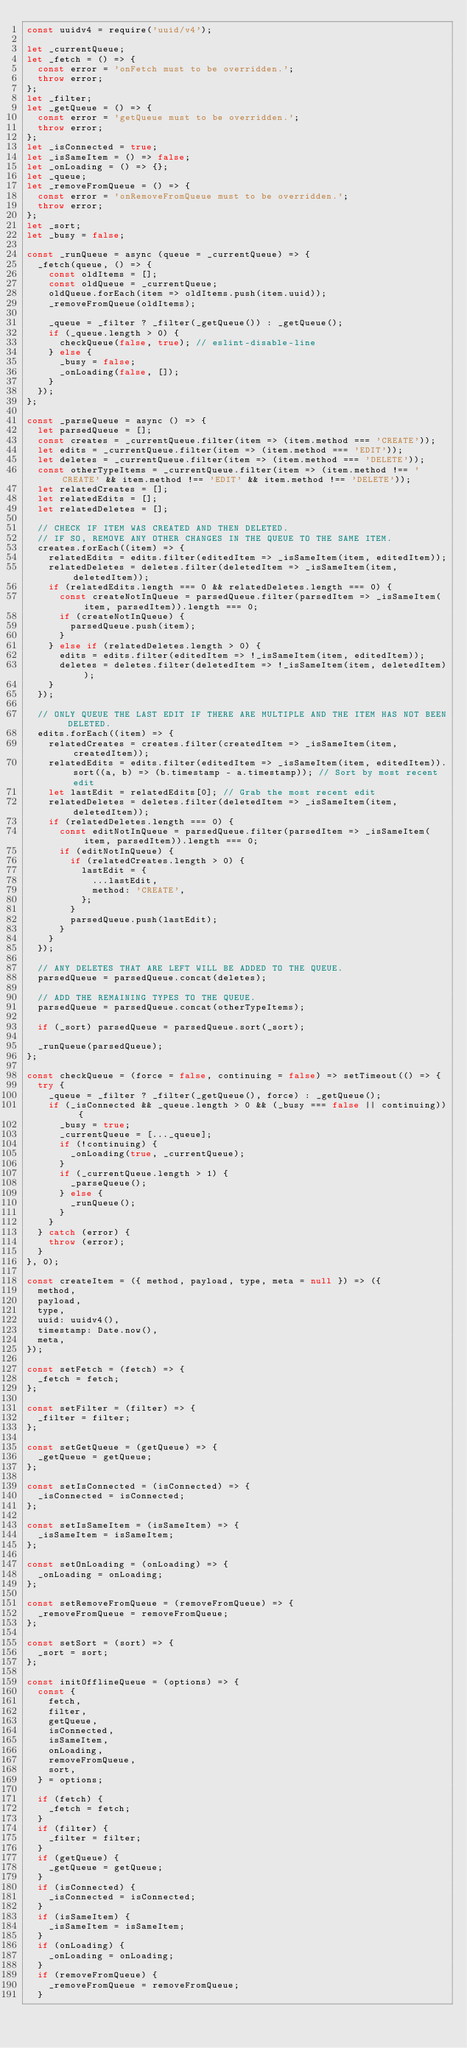Convert code to text. <code><loc_0><loc_0><loc_500><loc_500><_JavaScript_>const uuidv4 = require('uuid/v4');

let _currentQueue;
let _fetch = () => {
  const error = 'onFetch must to be overridden.';
  throw error;
};
let _filter;
let _getQueue = () => {
  const error = 'getQueue must to be overridden.';
  throw error;
};
let _isConnected = true;
let _isSameItem = () => false;
let _onLoading = () => {};
let _queue;
let _removeFromQueue = () => {
  const error = 'onRemoveFromQueue must to be overridden.';
  throw error;
};
let _sort;
let _busy = false;

const _runQueue = async (queue = _currentQueue) => {
  _fetch(queue, () => {
    const oldItems = [];
    const oldQueue = _currentQueue;
    oldQueue.forEach(item => oldItems.push(item.uuid));
    _removeFromQueue(oldItems);

    _queue = _filter ? _filter(_getQueue()) : _getQueue();
    if (_queue.length > 0) {
      checkQueue(false, true); // eslint-disable-line
    } else {
      _busy = false;
      _onLoading(false, []);
    }
  });
};

const _parseQueue = async () => {
  let parsedQueue = [];
  const creates = _currentQueue.filter(item => (item.method === 'CREATE'));
  let edits = _currentQueue.filter(item => (item.method === 'EDIT'));
  let deletes = _currentQueue.filter(item => (item.method === 'DELETE'));
  const otherTypeItems = _currentQueue.filter(item => (item.method !== 'CREATE' && item.method !== 'EDIT' && item.method !== 'DELETE'));
  let relatedCreates = [];
  let relatedEdits = [];
  let relatedDeletes = [];

  // CHECK IF ITEM WAS CREATED AND THEN DELETED.
  // IF SO, REMOVE ANY OTHER CHANGES IN THE QUEUE TO THE SAME ITEM.
  creates.forEach((item) => {
    relatedEdits = edits.filter(editedItem => _isSameItem(item, editedItem));
    relatedDeletes = deletes.filter(deletedItem => _isSameItem(item, deletedItem));
    if (relatedEdits.length === 0 && relatedDeletes.length === 0) {
      const createNotInQueue = parsedQueue.filter(parsedItem => _isSameItem(item, parsedItem)).length === 0;
      if (createNotInQueue) {
        parsedQueue.push(item);
      }
    } else if (relatedDeletes.length > 0) {
      edits = edits.filter(editedItem => !_isSameItem(item, editedItem));
      deletes = deletes.filter(deletedItem => !_isSameItem(item, deletedItem));
    }
  });

  // ONLY QUEUE THE LAST EDIT IF THERE ARE MULTIPLE AND THE ITEM HAS NOT BEEN DELETED.
  edits.forEach((item) => {
    relatedCreates = creates.filter(createdItem => _isSameItem(item, createdItem));
    relatedEdits = edits.filter(editedItem => _isSameItem(item, editedItem)).sort((a, b) => (b.timestamp - a.timestamp)); // Sort by most recent edit
    let lastEdit = relatedEdits[0]; // Grab the most recent edit
    relatedDeletes = deletes.filter(deletedItem => _isSameItem(item, deletedItem));
    if (relatedDeletes.length === 0) {
      const editNotInQueue = parsedQueue.filter(parsedItem => _isSameItem(item, parsedItem)).length === 0;
      if (editNotInQueue) {
        if (relatedCreates.length > 0) {
          lastEdit = {
            ...lastEdit,
            method: 'CREATE',
          };
        }
        parsedQueue.push(lastEdit);
      }
    }
  });

  // ANY DELETES THAT ARE LEFT WILL BE ADDED TO THE QUEUE.
  parsedQueue = parsedQueue.concat(deletes);

  // ADD THE REMAINING TYPES TO THE QUEUE.
  parsedQueue = parsedQueue.concat(otherTypeItems);

  if (_sort) parsedQueue = parsedQueue.sort(_sort);

  _runQueue(parsedQueue);
};

const checkQueue = (force = false, continuing = false) => setTimeout(() => {
  try {
    _queue = _filter ? _filter(_getQueue(), force) : _getQueue();
    if (_isConnected && _queue.length > 0 && (_busy === false || continuing)) {
      _busy = true;
      _currentQueue = [..._queue];
      if (!continuing) {
        _onLoading(true, _currentQueue);
      }
      if (_currentQueue.length > 1) {
        _parseQueue();
      } else {
        _runQueue();
      }
    }
  } catch (error) {
    throw (error);
  }
}, 0);

const createItem = ({ method, payload, type, meta = null }) => ({
  method,
  payload,
  type,
  uuid: uuidv4(),
  timestamp: Date.now(),
  meta,
});

const setFetch = (fetch) => {
  _fetch = fetch;
};

const setFilter = (filter) => {
  _filter = filter;
};

const setGetQueue = (getQueue) => {
  _getQueue = getQueue;
};

const setIsConnected = (isConnected) => {
  _isConnected = isConnected;
};

const setIsSameItem = (isSameItem) => {
  _isSameItem = isSameItem;
};

const setOnLoading = (onLoading) => {
  _onLoading = onLoading;
};

const setRemoveFromQueue = (removeFromQueue) => {
  _removeFromQueue = removeFromQueue;
};

const setSort = (sort) => {
  _sort = sort;
};

const initOfflineQueue = (options) => {
  const {
    fetch,
    filter,
    getQueue,
    isConnected,
    isSameItem,
    onLoading,
    removeFromQueue,
    sort,
  } = options;

  if (fetch) {
    _fetch = fetch;
  }
  if (filter) {
    _filter = filter;
  }
  if (getQueue) {
    _getQueue = getQueue;
  }
  if (isConnected) {
    _isConnected = isConnected;
  }
  if (isSameItem) {
    _isSameItem = isSameItem;
  }
  if (onLoading) {
    _onLoading = onLoading;
  }
  if (removeFromQueue) {
    _removeFromQueue = removeFromQueue;
  }</code> 